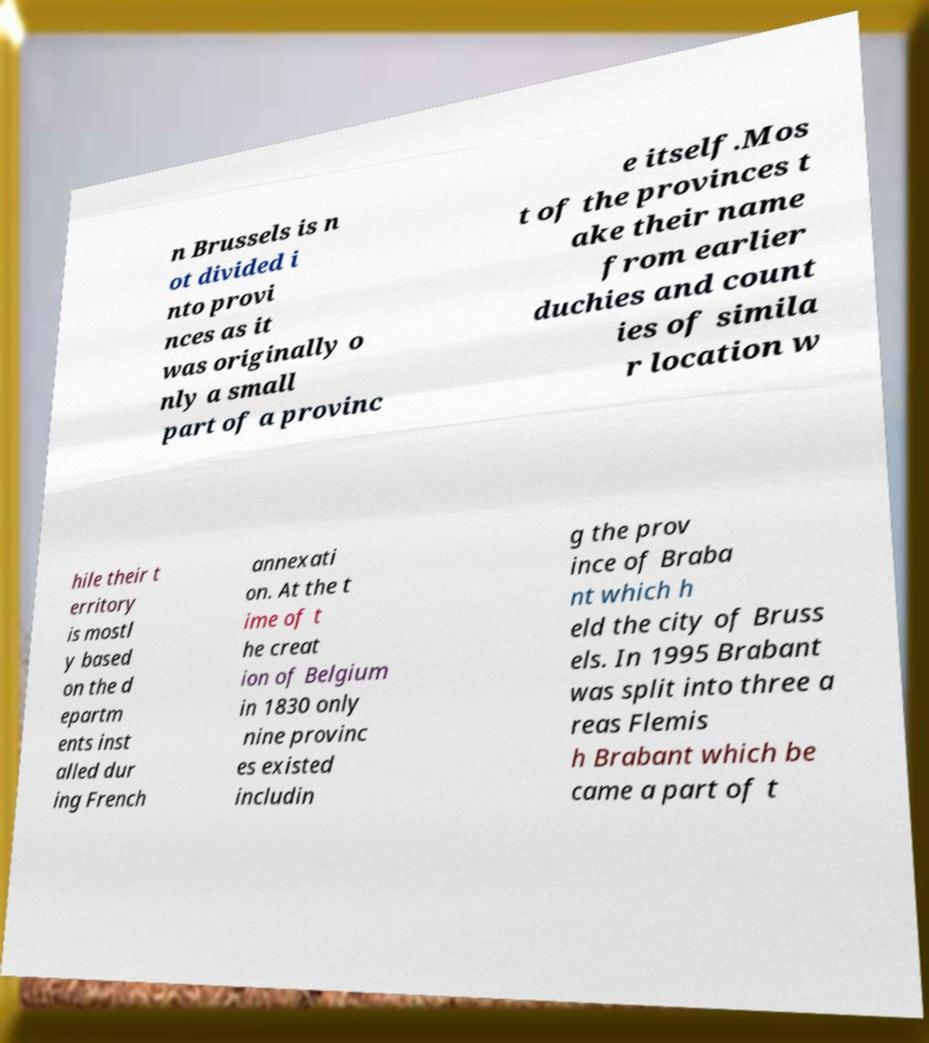What messages or text are displayed in this image? I need them in a readable, typed format. n Brussels is n ot divided i nto provi nces as it was originally o nly a small part of a provinc e itself.Mos t of the provinces t ake their name from earlier duchies and count ies of simila r location w hile their t erritory is mostl y based on the d epartm ents inst alled dur ing French annexati on. At the t ime of t he creat ion of Belgium in 1830 only nine provinc es existed includin g the prov ince of Braba nt which h eld the city of Bruss els. In 1995 Brabant was split into three a reas Flemis h Brabant which be came a part of t 